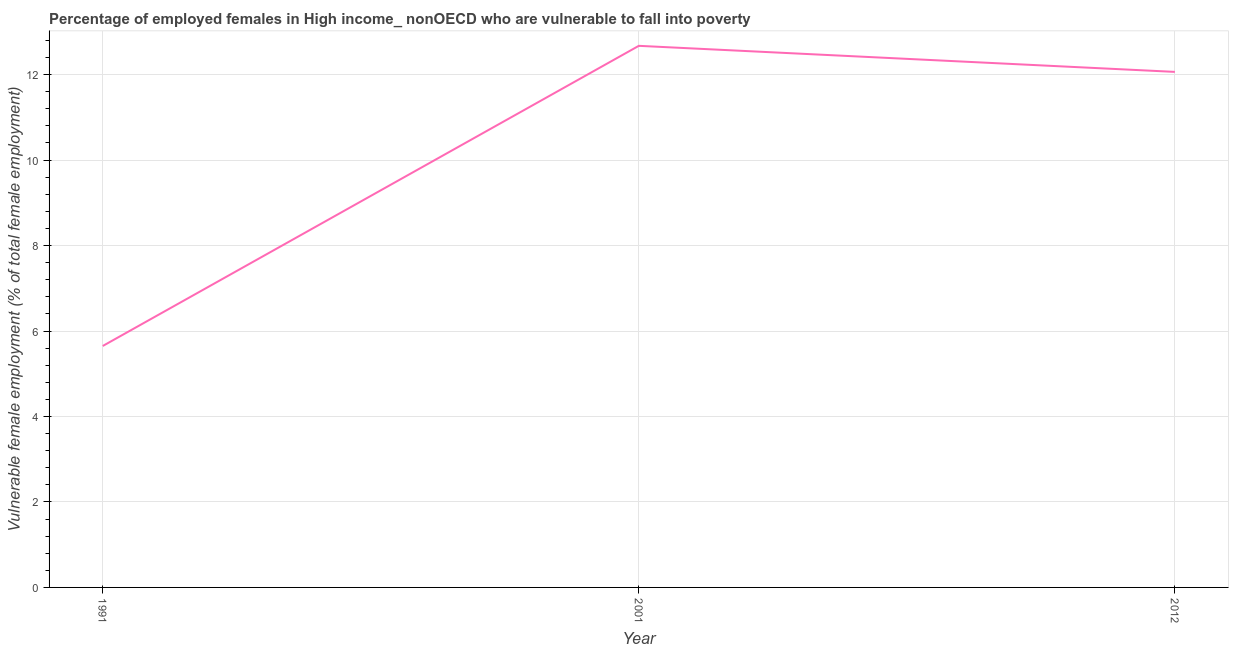What is the percentage of employed females who are vulnerable to fall into poverty in 2012?
Provide a short and direct response. 12.06. Across all years, what is the maximum percentage of employed females who are vulnerable to fall into poverty?
Ensure brevity in your answer.  12.67. Across all years, what is the minimum percentage of employed females who are vulnerable to fall into poverty?
Your response must be concise. 5.65. In which year was the percentage of employed females who are vulnerable to fall into poverty maximum?
Your answer should be compact. 2001. In which year was the percentage of employed females who are vulnerable to fall into poverty minimum?
Provide a succinct answer. 1991. What is the sum of the percentage of employed females who are vulnerable to fall into poverty?
Keep it short and to the point. 30.39. What is the difference between the percentage of employed females who are vulnerable to fall into poverty in 1991 and 2012?
Ensure brevity in your answer.  -6.41. What is the average percentage of employed females who are vulnerable to fall into poverty per year?
Your answer should be very brief. 10.13. What is the median percentage of employed females who are vulnerable to fall into poverty?
Ensure brevity in your answer.  12.06. In how many years, is the percentage of employed females who are vulnerable to fall into poverty greater than 6.4 %?
Keep it short and to the point. 2. What is the ratio of the percentage of employed females who are vulnerable to fall into poverty in 2001 to that in 2012?
Offer a terse response. 1.05. What is the difference between the highest and the second highest percentage of employed females who are vulnerable to fall into poverty?
Give a very brief answer. 0.61. What is the difference between the highest and the lowest percentage of employed females who are vulnerable to fall into poverty?
Provide a succinct answer. 7.02. In how many years, is the percentage of employed females who are vulnerable to fall into poverty greater than the average percentage of employed females who are vulnerable to fall into poverty taken over all years?
Give a very brief answer. 2. What is the title of the graph?
Offer a terse response. Percentage of employed females in High income_ nonOECD who are vulnerable to fall into poverty. What is the label or title of the Y-axis?
Give a very brief answer. Vulnerable female employment (% of total female employment). What is the Vulnerable female employment (% of total female employment) in 1991?
Your answer should be very brief. 5.65. What is the Vulnerable female employment (% of total female employment) of 2001?
Offer a very short reply. 12.67. What is the Vulnerable female employment (% of total female employment) of 2012?
Offer a terse response. 12.06. What is the difference between the Vulnerable female employment (% of total female employment) in 1991 and 2001?
Make the answer very short. -7.02. What is the difference between the Vulnerable female employment (% of total female employment) in 1991 and 2012?
Ensure brevity in your answer.  -6.41. What is the difference between the Vulnerable female employment (% of total female employment) in 2001 and 2012?
Ensure brevity in your answer.  0.61. What is the ratio of the Vulnerable female employment (% of total female employment) in 1991 to that in 2001?
Your response must be concise. 0.45. What is the ratio of the Vulnerable female employment (% of total female employment) in 1991 to that in 2012?
Provide a succinct answer. 0.47. What is the ratio of the Vulnerable female employment (% of total female employment) in 2001 to that in 2012?
Provide a short and direct response. 1.05. 